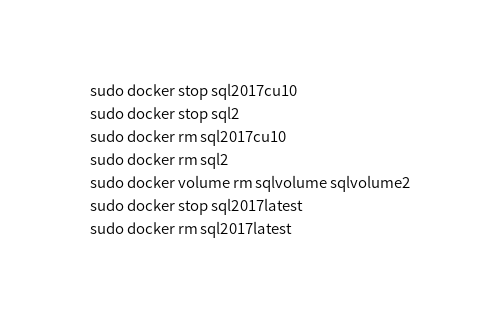Convert code to text. <code><loc_0><loc_0><loc_500><loc_500><_Bash_>sudo docker stop sql2017cu10
sudo docker stop sql2
sudo docker rm sql2017cu10
sudo docker rm sql2
sudo docker volume rm sqlvolume sqlvolume2
sudo docker stop sql2017latest
sudo docker rm sql2017latest
</code> 